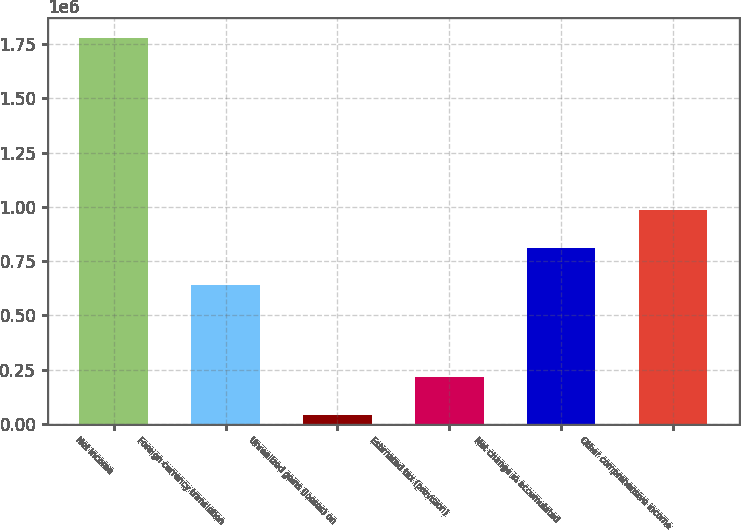<chart> <loc_0><loc_0><loc_500><loc_500><bar_chart><fcel>Net income<fcel>Foreign currency translation<fcel>Unrealized gains (losses) on<fcel>Estimated tax (provision)<fcel>Net change in accumulated<fcel>Other comprehensive income<nl><fcel>1.77947e+06<fcel>638066<fcel>40522<fcel>214417<fcel>811961<fcel>985857<nl></chart> 